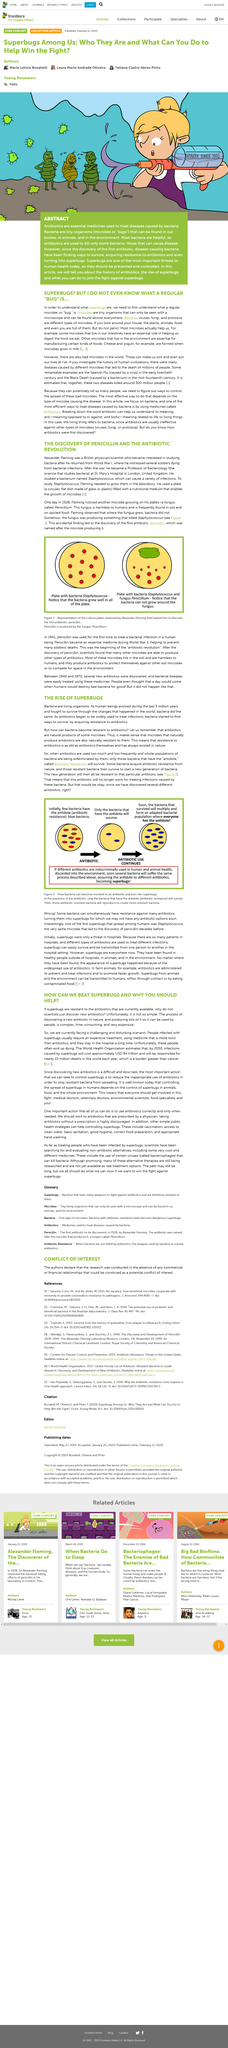Highlight a few significant elements in this photo. The Black Death and Spanish Flu collectively resulted in the deaths of approximately 300 million people worldwide. Andrew Fleming, a Professor of Bacteriology, received his education at St. Mary's Hospital in London, United Kingdom, where he studied to become a professor in the field of bacteriology. It is projected that by 2050, the cost of infections caused by superbugs will reach approximately USD 84 trillion. The subject of the study was Staphylococcus, and the fungus that caused its demise was named Penicillium. The term "bacteria have an antidote" refers to the fact that they have developed a natural resistance to antibiotics through evolution, which allows them to survive and thrive in the presence of these substances that would otherwise harm them. 